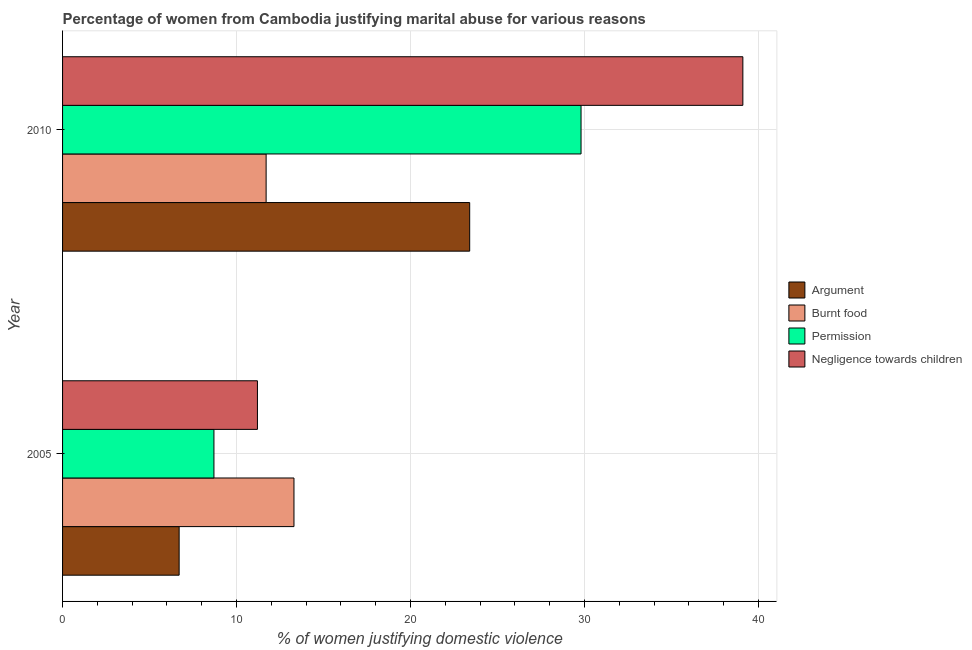How many groups of bars are there?
Your answer should be very brief. 2. Are the number of bars per tick equal to the number of legend labels?
Make the answer very short. Yes. What is the label of the 2nd group of bars from the top?
Provide a short and direct response. 2005. What is the percentage of women justifying abuse for showing negligence towards children in 2010?
Provide a short and direct response. 39.1. Across all years, what is the maximum percentage of women justifying abuse for showing negligence towards children?
Offer a terse response. 39.1. In which year was the percentage of women justifying abuse for showing negligence towards children minimum?
Keep it short and to the point. 2005. What is the total percentage of women justifying abuse for going without permission in the graph?
Provide a succinct answer. 38.5. What is the difference between the percentage of women justifying abuse for going without permission in 2005 and that in 2010?
Your answer should be compact. -21.1. What is the average percentage of women justifying abuse for going without permission per year?
Offer a terse response. 19.25. In how many years, is the percentage of women justifying abuse in the case of an argument greater than 2 %?
Keep it short and to the point. 2. What is the ratio of the percentage of women justifying abuse for going without permission in 2005 to that in 2010?
Your response must be concise. 0.29. Is the difference between the percentage of women justifying abuse for burning food in 2005 and 2010 greater than the difference between the percentage of women justifying abuse for going without permission in 2005 and 2010?
Your response must be concise. Yes. What does the 3rd bar from the top in 2005 represents?
Offer a terse response. Burnt food. What does the 4th bar from the bottom in 2010 represents?
Offer a terse response. Negligence towards children. How many bars are there?
Provide a succinct answer. 8. How many years are there in the graph?
Your answer should be compact. 2. Does the graph contain any zero values?
Your answer should be compact. No. How are the legend labels stacked?
Offer a terse response. Vertical. What is the title of the graph?
Give a very brief answer. Percentage of women from Cambodia justifying marital abuse for various reasons. Does "Other expenses" appear as one of the legend labels in the graph?
Ensure brevity in your answer.  No. What is the label or title of the X-axis?
Ensure brevity in your answer.  % of women justifying domestic violence. What is the label or title of the Y-axis?
Your response must be concise. Year. What is the % of women justifying domestic violence of Argument in 2010?
Ensure brevity in your answer.  23.4. What is the % of women justifying domestic violence in Burnt food in 2010?
Your answer should be very brief. 11.7. What is the % of women justifying domestic violence of Permission in 2010?
Your response must be concise. 29.8. What is the % of women justifying domestic violence of Negligence towards children in 2010?
Offer a terse response. 39.1. Across all years, what is the maximum % of women justifying domestic violence in Argument?
Offer a very short reply. 23.4. Across all years, what is the maximum % of women justifying domestic violence of Burnt food?
Your response must be concise. 13.3. Across all years, what is the maximum % of women justifying domestic violence of Permission?
Give a very brief answer. 29.8. Across all years, what is the maximum % of women justifying domestic violence in Negligence towards children?
Your response must be concise. 39.1. Across all years, what is the minimum % of women justifying domestic violence in Argument?
Your response must be concise. 6.7. Across all years, what is the minimum % of women justifying domestic violence in Permission?
Ensure brevity in your answer.  8.7. Across all years, what is the minimum % of women justifying domestic violence of Negligence towards children?
Ensure brevity in your answer.  11.2. What is the total % of women justifying domestic violence in Argument in the graph?
Your response must be concise. 30.1. What is the total % of women justifying domestic violence of Burnt food in the graph?
Your answer should be compact. 25. What is the total % of women justifying domestic violence in Permission in the graph?
Your answer should be very brief. 38.5. What is the total % of women justifying domestic violence of Negligence towards children in the graph?
Your answer should be very brief. 50.3. What is the difference between the % of women justifying domestic violence in Argument in 2005 and that in 2010?
Give a very brief answer. -16.7. What is the difference between the % of women justifying domestic violence in Burnt food in 2005 and that in 2010?
Your answer should be very brief. 1.6. What is the difference between the % of women justifying domestic violence in Permission in 2005 and that in 2010?
Give a very brief answer. -21.1. What is the difference between the % of women justifying domestic violence of Negligence towards children in 2005 and that in 2010?
Offer a very short reply. -27.9. What is the difference between the % of women justifying domestic violence in Argument in 2005 and the % of women justifying domestic violence in Burnt food in 2010?
Your answer should be compact. -5. What is the difference between the % of women justifying domestic violence of Argument in 2005 and the % of women justifying domestic violence of Permission in 2010?
Offer a very short reply. -23.1. What is the difference between the % of women justifying domestic violence of Argument in 2005 and the % of women justifying domestic violence of Negligence towards children in 2010?
Provide a succinct answer. -32.4. What is the difference between the % of women justifying domestic violence of Burnt food in 2005 and the % of women justifying domestic violence of Permission in 2010?
Provide a succinct answer. -16.5. What is the difference between the % of women justifying domestic violence of Burnt food in 2005 and the % of women justifying domestic violence of Negligence towards children in 2010?
Offer a very short reply. -25.8. What is the difference between the % of women justifying domestic violence in Permission in 2005 and the % of women justifying domestic violence in Negligence towards children in 2010?
Ensure brevity in your answer.  -30.4. What is the average % of women justifying domestic violence in Argument per year?
Make the answer very short. 15.05. What is the average % of women justifying domestic violence in Permission per year?
Your answer should be compact. 19.25. What is the average % of women justifying domestic violence of Negligence towards children per year?
Provide a short and direct response. 25.15. In the year 2005, what is the difference between the % of women justifying domestic violence of Argument and % of women justifying domestic violence of Negligence towards children?
Make the answer very short. -4.5. In the year 2005, what is the difference between the % of women justifying domestic violence in Permission and % of women justifying domestic violence in Negligence towards children?
Ensure brevity in your answer.  -2.5. In the year 2010, what is the difference between the % of women justifying domestic violence of Argument and % of women justifying domestic violence of Burnt food?
Make the answer very short. 11.7. In the year 2010, what is the difference between the % of women justifying domestic violence in Argument and % of women justifying domestic violence in Negligence towards children?
Your response must be concise. -15.7. In the year 2010, what is the difference between the % of women justifying domestic violence in Burnt food and % of women justifying domestic violence in Permission?
Your response must be concise. -18.1. In the year 2010, what is the difference between the % of women justifying domestic violence in Burnt food and % of women justifying domestic violence in Negligence towards children?
Keep it short and to the point. -27.4. In the year 2010, what is the difference between the % of women justifying domestic violence in Permission and % of women justifying domestic violence in Negligence towards children?
Offer a very short reply. -9.3. What is the ratio of the % of women justifying domestic violence of Argument in 2005 to that in 2010?
Make the answer very short. 0.29. What is the ratio of the % of women justifying domestic violence in Burnt food in 2005 to that in 2010?
Provide a short and direct response. 1.14. What is the ratio of the % of women justifying domestic violence in Permission in 2005 to that in 2010?
Your answer should be compact. 0.29. What is the ratio of the % of women justifying domestic violence in Negligence towards children in 2005 to that in 2010?
Provide a succinct answer. 0.29. What is the difference between the highest and the second highest % of women justifying domestic violence of Argument?
Give a very brief answer. 16.7. What is the difference between the highest and the second highest % of women justifying domestic violence of Burnt food?
Keep it short and to the point. 1.6. What is the difference between the highest and the second highest % of women justifying domestic violence in Permission?
Offer a very short reply. 21.1. What is the difference between the highest and the second highest % of women justifying domestic violence in Negligence towards children?
Provide a short and direct response. 27.9. What is the difference between the highest and the lowest % of women justifying domestic violence of Permission?
Ensure brevity in your answer.  21.1. What is the difference between the highest and the lowest % of women justifying domestic violence in Negligence towards children?
Provide a succinct answer. 27.9. 